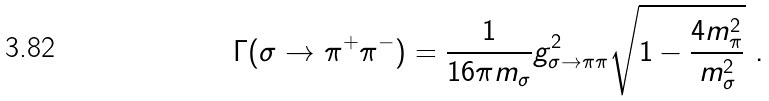Convert formula to latex. <formula><loc_0><loc_0><loc_500><loc_500>\Gamma ( \sigma \rightarrow \pi ^ { + } \pi ^ { - } ) = \frac { 1 } { 1 6 \pi m _ { \sigma } } g _ { \sigma \rightarrow \pi \pi } ^ { 2 } \sqrt { 1 - \frac { 4 m _ { \pi } ^ { 2 } } { m _ { \sigma } ^ { 2 } } } \ .</formula> 